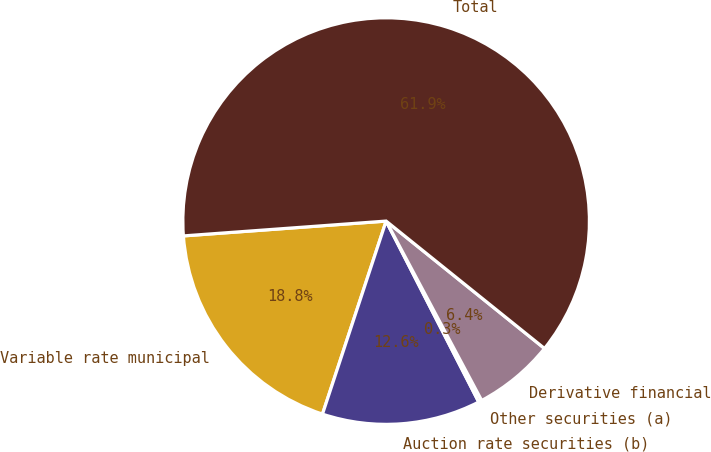Convert chart. <chart><loc_0><loc_0><loc_500><loc_500><pie_chart><fcel>Variable rate municipal<fcel>Auction rate securities (b)<fcel>Other securities (a)<fcel>Derivative financial<fcel>Total<nl><fcel>18.77%<fcel>12.6%<fcel>0.26%<fcel>6.43%<fcel>61.95%<nl></chart> 